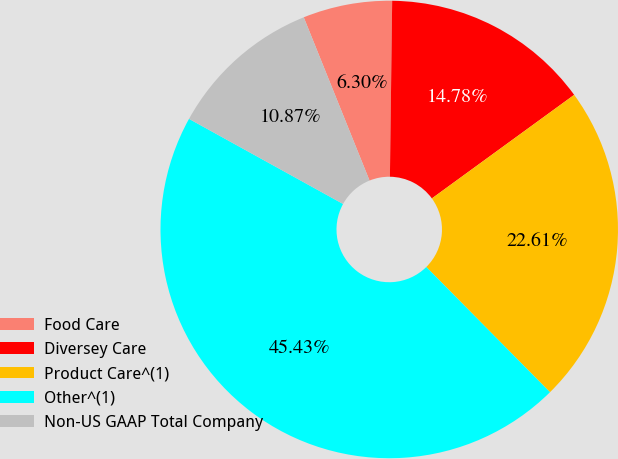<chart> <loc_0><loc_0><loc_500><loc_500><pie_chart><fcel>Food Care<fcel>Diversey Care<fcel>Product Care^(1)<fcel>Other^(1)<fcel>Non-US GAAP Total Company<nl><fcel>6.3%<fcel>14.78%<fcel>22.61%<fcel>45.43%<fcel>10.87%<nl></chart> 